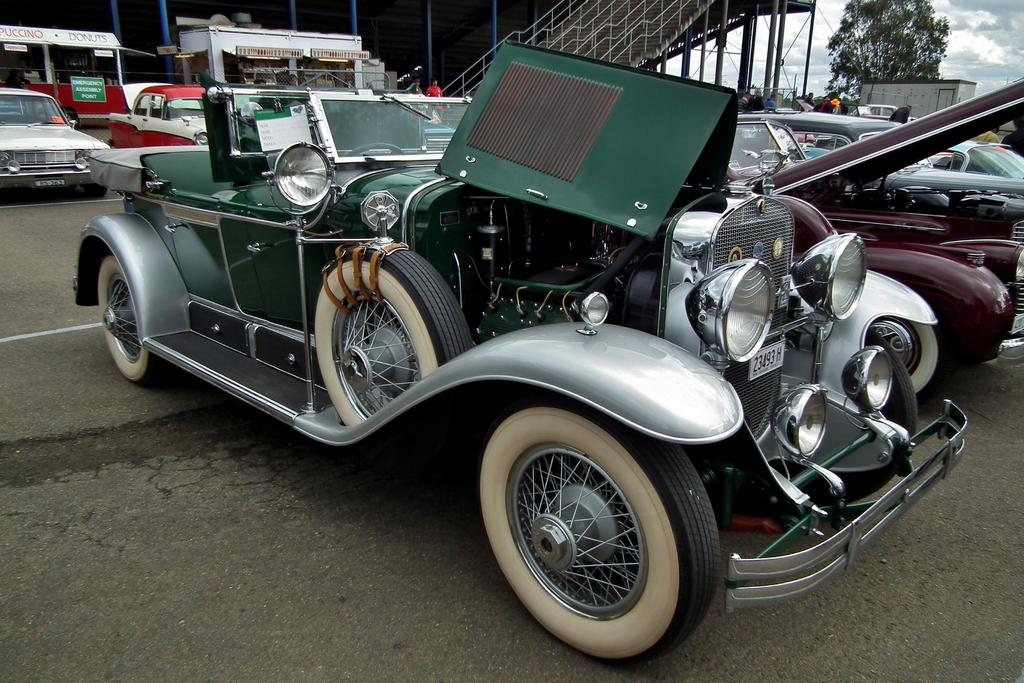What can be seen in the image in terms of transportation? There are many vehicles in the image. Can you describe the color of the front vehicle? The front vehicle is green. What type of natural scenery is visible in the background of the image? There are trees in the background of the image, and they are green. What type of structure can be seen in the background of the image? There is a building in the background of the image, and it is white. What is visible in the sky in the background of the image? The sky is visible in the background of the image, and it has both white and gray colors. How does the crowd in the image change the color of the flesh? There is no crowd present in the image, and therefore no such interaction can be observed. 